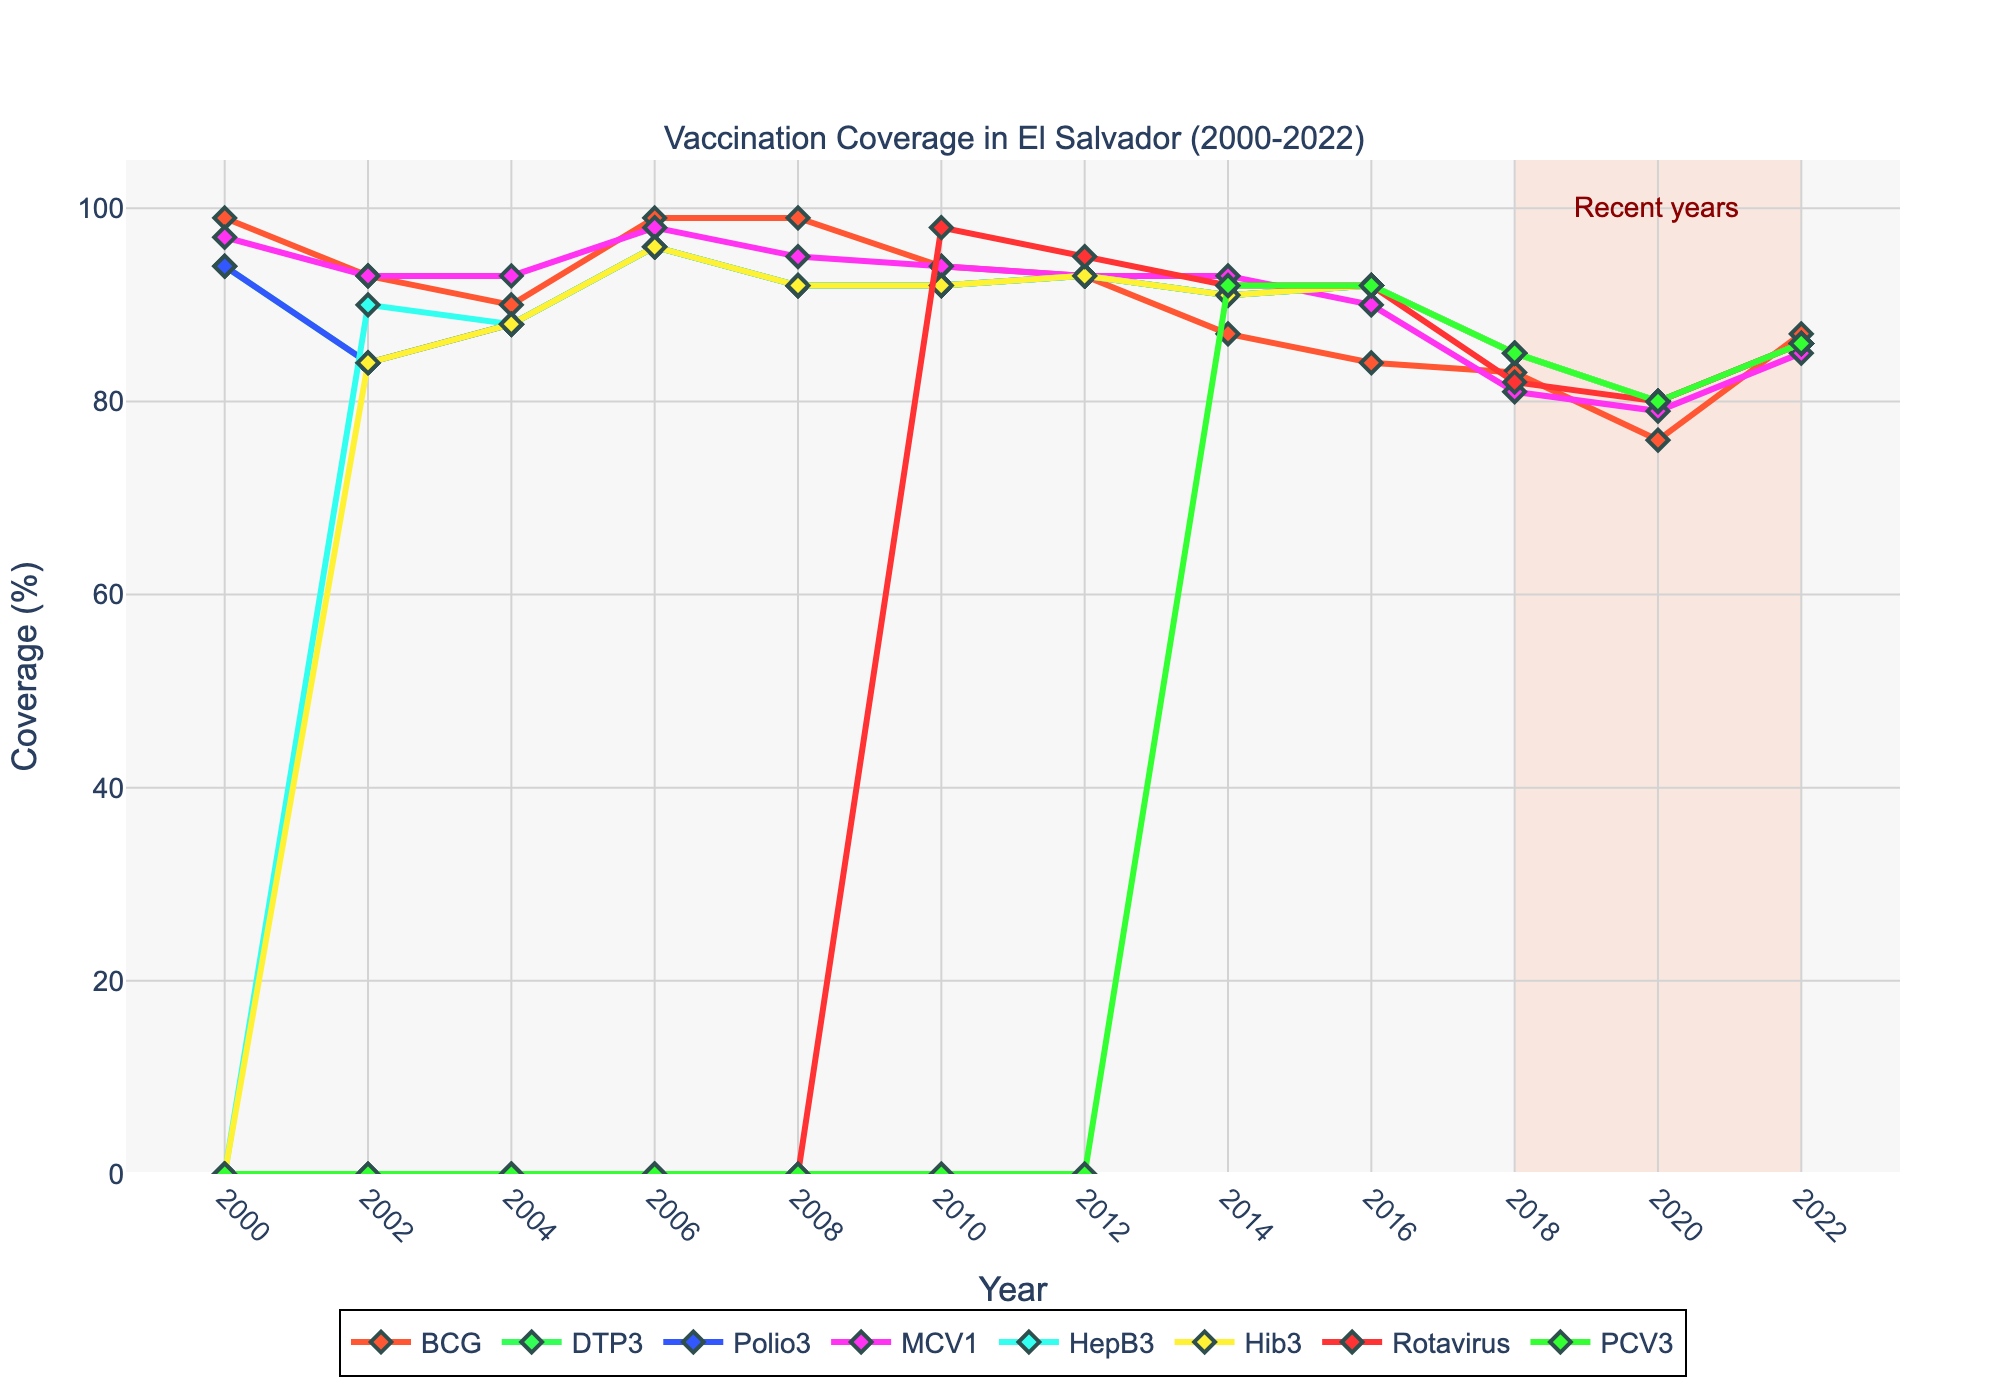What vaccine had the highest coverage in the year 2000? The figure shows different lines for each vaccine type. By looking at the markers for the year 2000, we see that BCG had the highest coverage.
Answer: BCG Between which years did the DTP3 coverage rate see the most significant decrease? Observing the DTP3 line, the steepest decline in coverage occurs between the years 2000 (94%) and 2002 (84%).
Answer: 2000-2002 Which vaccine coverage showed a continuous drop from 2008 to 2020? By examining the lines for all vaccines, Polio3 had a consistent drop from 2008 (92%) to 2020 (80%).
Answer: Polio3 In which year did both Rotavirus and PCV3 coverage reach the same value? Observing the plot, both Rotavirus and PCV3 had a coverage of 92% in the year 2014.
Answer: 2014 What is the average coverage rate of MCV1 from 2008 to 2020? Looking at the MCV1 values for the years 2008 to 2020 (95, 94, 93, 93, 90, 81, 79, 85), summing them gives 710, and dividing by the 8 years gives an average of 88.75.
Answer: 88.75 Identify the range of years highlighted by the rectangle in the plot. The highlighted area starts at 2018 and ends at 2022.
Answer: 2018-2022 Which two vaccines had the most similar coverage rates in 2022? Checking the values for 2022, all the vaccines (BCG, DTP3, Polio3, MCV1, HepB3, Hib3, Rotavirus, PCV3) had the same coverage rate of 86%.
Answer: All vaccines What visual feature indicates a specific focus on recent years in the plot? The rectangle shaded in light salmon from 2018 to 2022 indicates a focus on recent years.
Answer: Light salmon rectangle Which vaccine had a significant introduction showing up with high initial coverage after 2000? Rotavirus was introduced later and had a high coverage of 98% in 2010.
Answer: Rotavirus What trend is observed in the BCG coverage from 2000 to 2020? The BCG line shows a downward trend, starting at 99% in 2000 and decreasing to 76% in 2020.
Answer: Downward trend 